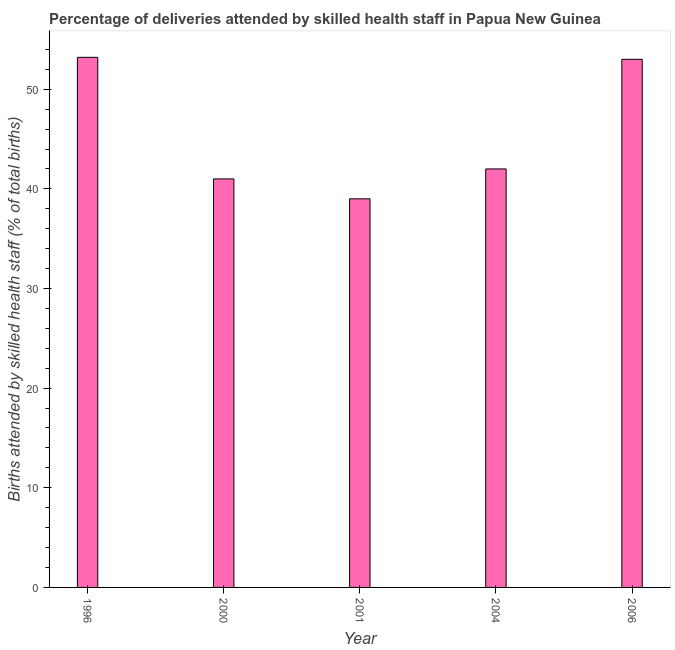Does the graph contain any zero values?
Ensure brevity in your answer.  No. Does the graph contain grids?
Offer a very short reply. No. What is the title of the graph?
Offer a terse response. Percentage of deliveries attended by skilled health staff in Papua New Guinea. What is the label or title of the Y-axis?
Provide a succinct answer. Births attended by skilled health staff (% of total births). Across all years, what is the maximum number of births attended by skilled health staff?
Your answer should be very brief. 53.2. Across all years, what is the minimum number of births attended by skilled health staff?
Make the answer very short. 39. What is the sum of the number of births attended by skilled health staff?
Provide a succinct answer. 228.2. What is the difference between the number of births attended by skilled health staff in 2001 and 2006?
Your response must be concise. -14. What is the average number of births attended by skilled health staff per year?
Your answer should be compact. 45.64. Do a majority of the years between 2004 and 1996 (inclusive) have number of births attended by skilled health staff greater than 10 %?
Your response must be concise. Yes. What is the ratio of the number of births attended by skilled health staff in 1996 to that in 2004?
Your answer should be compact. 1.27. Is the difference between the number of births attended by skilled health staff in 1996 and 2006 greater than the difference between any two years?
Provide a succinct answer. No. What is the difference between the highest and the second highest number of births attended by skilled health staff?
Provide a succinct answer. 0.2. Is the sum of the number of births attended by skilled health staff in 1996 and 2006 greater than the maximum number of births attended by skilled health staff across all years?
Your answer should be very brief. Yes. Are all the bars in the graph horizontal?
Your answer should be compact. No. How many years are there in the graph?
Give a very brief answer. 5. Are the values on the major ticks of Y-axis written in scientific E-notation?
Your answer should be compact. No. What is the Births attended by skilled health staff (% of total births) in 1996?
Offer a terse response. 53.2. What is the Births attended by skilled health staff (% of total births) of 2001?
Offer a very short reply. 39. What is the Births attended by skilled health staff (% of total births) in 2004?
Make the answer very short. 42. What is the difference between the Births attended by skilled health staff (% of total births) in 1996 and 2004?
Offer a terse response. 11.2. What is the difference between the Births attended by skilled health staff (% of total births) in 1996 and 2006?
Keep it short and to the point. 0.2. What is the difference between the Births attended by skilled health staff (% of total births) in 2001 and 2004?
Give a very brief answer. -3. What is the difference between the Births attended by skilled health staff (% of total births) in 2001 and 2006?
Make the answer very short. -14. What is the difference between the Births attended by skilled health staff (% of total births) in 2004 and 2006?
Make the answer very short. -11. What is the ratio of the Births attended by skilled health staff (% of total births) in 1996 to that in 2000?
Keep it short and to the point. 1.3. What is the ratio of the Births attended by skilled health staff (% of total births) in 1996 to that in 2001?
Make the answer very short. 1.36. What is the ratio of the Births attended by skilled health staff (% of total births) in 1996 to that in 2004?
Your response must be concise. 1.27. What is the ratio of the Births attended by skilled health staff (% of total births) in 1996 to that in 2006?
Make the answer very short. 1. What is the ratio of the Births attended by skilled health staff (% of total births) in 2000 to that in 2001?
Keep it short and to the point. 1.05. What is the ratio of the Births attended by skilled health staff (% of total births) in 2000 to that in 2004?
Keep it short and to the point. 0.98. What is the ratio of the Births attended by skilled health staff (% of total births) in 2000 to that in 2006?
Provide a short and direct response. 0.77. What is the ratio of the Births attended by skilled health staff (% of total births) in 2001 to that in 2004?
Offer a terse response. 0.93. What is the ratio of the Births attended by skilled health staff (% of total births) in 2001 to that in 2006?
Provide a succinct answer. 0.74. What is the ratio of the Births attended by skilled health staff (% of total births) in 2004 to that in 2006?
Keep it short and to the point. 0.79. 